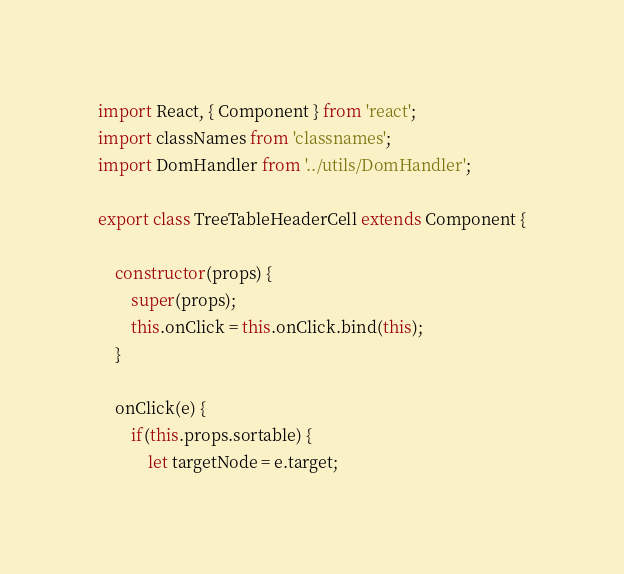<code> <loc_0><loc_0><loc_500><loc_500><_JavaScript_>import React, { Component } from 'react';
import classNames from 'classnames';
import DomHandler from '../utils/DomHandler';

export class TreeTableHeaderCell extends Component {

    constructor(props) {
        super(props);
        this.onClick = this.onClick.bind(this);
    }

    onClick(e) {
        if(this.props.sortable) {
            let targetNode = e.target;</code> 